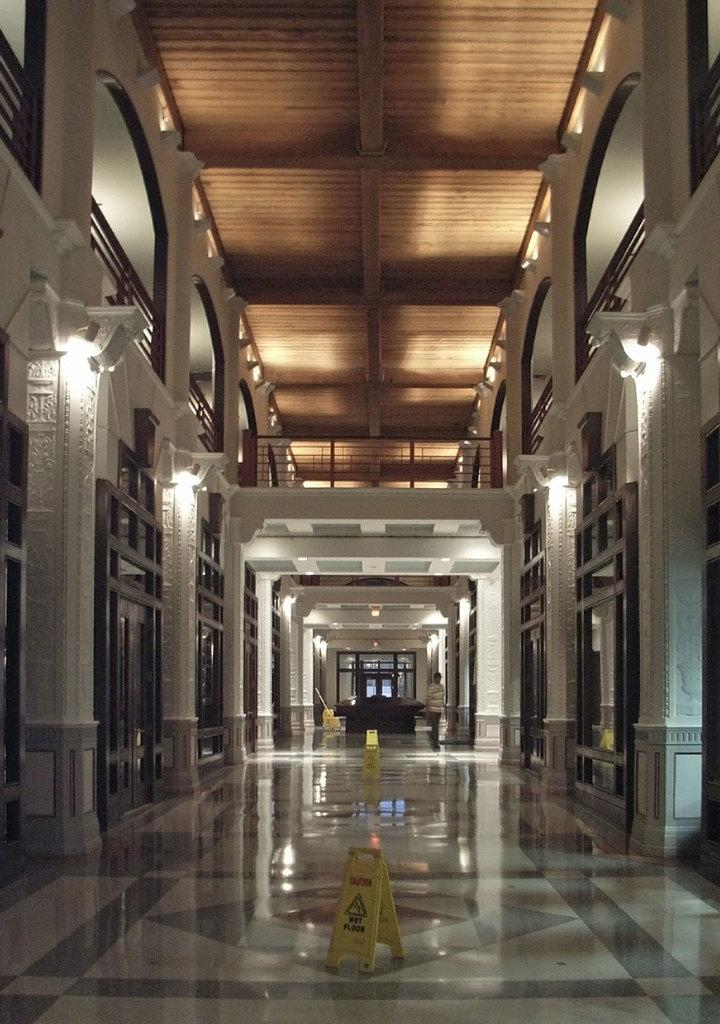What type of location is depicted in the image? The image shows an inner view of a building. Can you describe any people present in the image? There is a human standing in the image. What safety measures are in place in the depicted location? There are caution boards on the floor. What can be seen in terms of lighting in the image? There are lights visible in the image. What type of shelf can be seen holding tomatoes in the image? There is no shelf or tomatoes present in the image. 